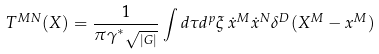Convert formula to latex. <formula><loc_0><loc_0><loc_500><loc_500>T ^ { M N } ( X ) = { \frac { 1 } { \pi \gamma ^ { \ast } \sqrt { _ { | G | } } } } \int d \tau d ^ { p } \xi \, \dot { x } ^ { M } \dot { x } ^ { N } \delta ^ { D } ( X ^ { M } - x ^ { M } )</formula> 